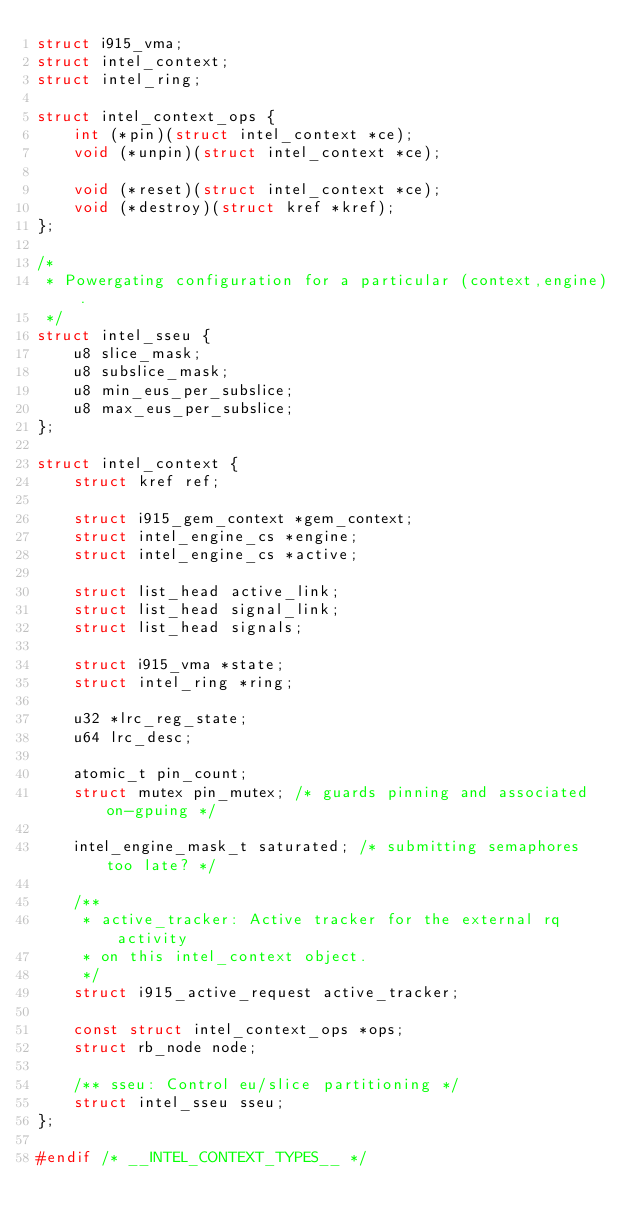Convert code to text. <code><loc_0><loc_0><loc_500><loc_500><_C_>struct i915_vma;
struct intel_context;
struct intel_ring;

struct intel_context_ops {
	int (*pin)(struct intel_context *ce);
	void (*unpin)(struct intel_context *ce);

	void (*reset)(struct intel_context *ce);
	void (*destroy)(struct kref *kref);
};

/*
 * Powergating configuration for a particular (context,engine).
 */
struct intel_sseu {
	u8 slice_mask;
	u8 subslice_mask;
	u8 min_eus_per_subslice;
	u8 max_eus_per_subslice;
};

struct intel_context {
	struct kref ref;

	struct i915_gem_context *gem_context;
	struct intel_engine_cs *engine;
	struct intel_engine_cs *active;

	struct list_head active_link;
	struct list_head signal_link;
	struct list_head signals;

	struct i915_vma *state;
	struct intel_ring *ring;

	u32 *lrc_reg_state;
	u64 lrc_desc;

	atomic_t pin_count;
	struct mutex pin_mutex; /* guards pinning and associated on-gpuing */

	intel_engine_mask_t saturated; /* submitting semaphores too late? */

	/**
	 * active_tracker: Active tracker for the external rq activity
	 * on this intel_context object.
	 */
	struct i915_active_request active_tracker;

	const struct intel_context_ops *ops;
	struct rb_node node;

	/** sseu: Control eu/slice partitioning */
	struct intel_sseu sseu;
};

#endif /* __INTEL_CONTEXT_TYPES__ */
</code> 